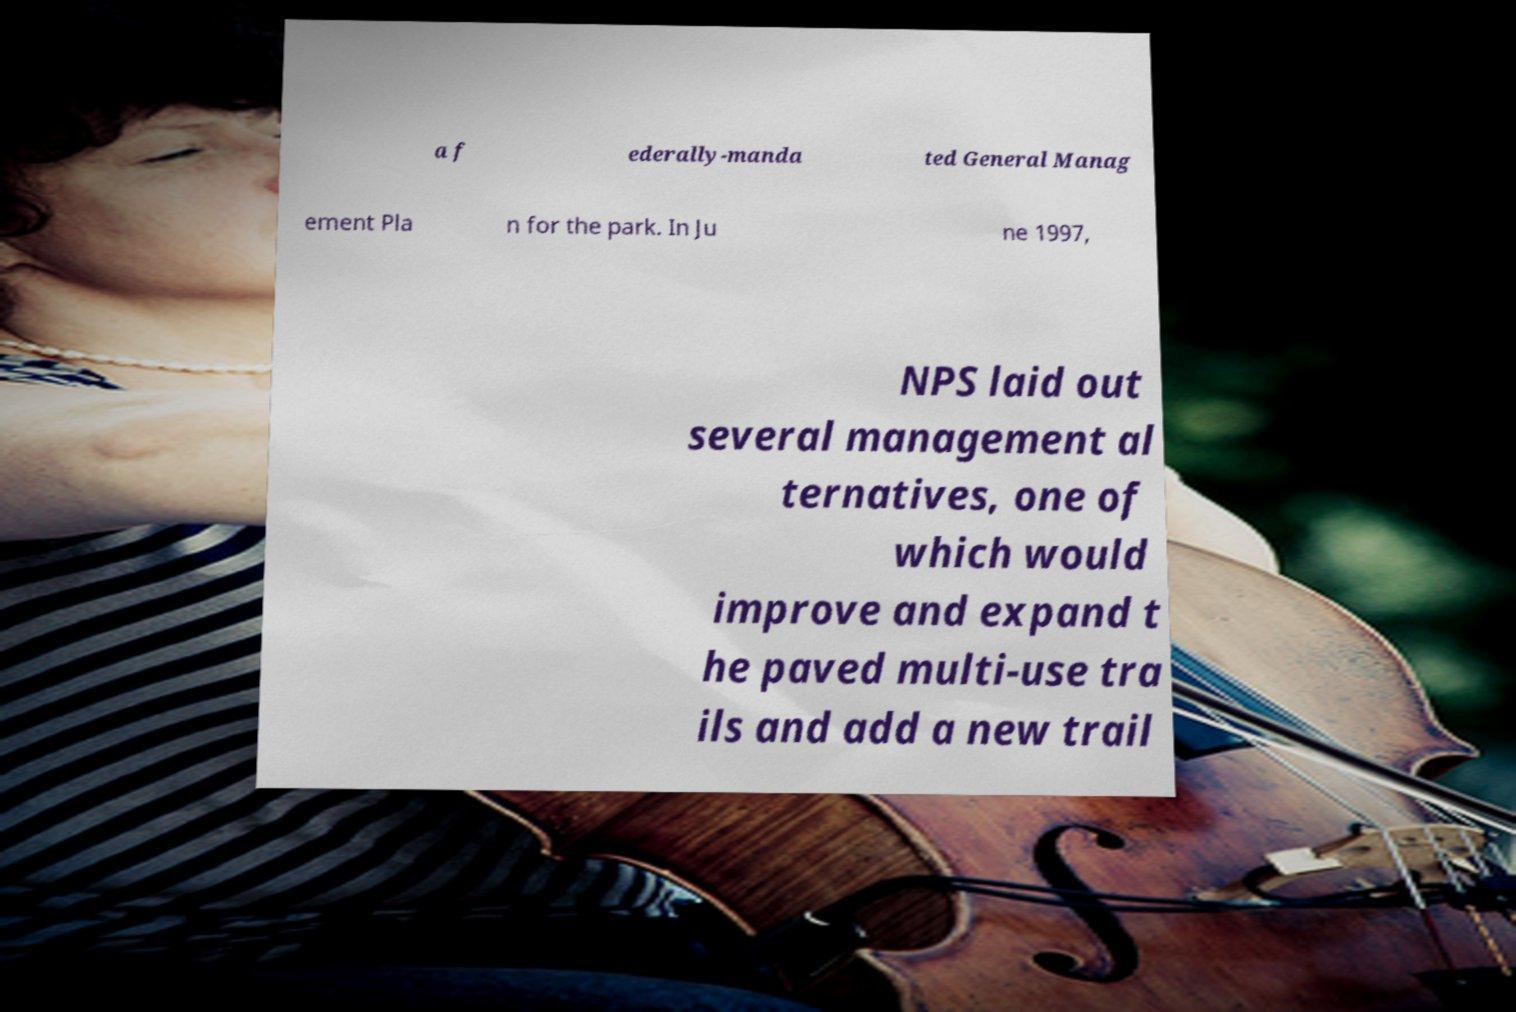Could you extract and type out the text from this image? a f ederally-manda ted General Manag ement Pla n for the park. In Ju ne 1997, NPS laid out several management al ternatives, one of which would improve and expand t he paved multi-use tra ils and add a new trail 